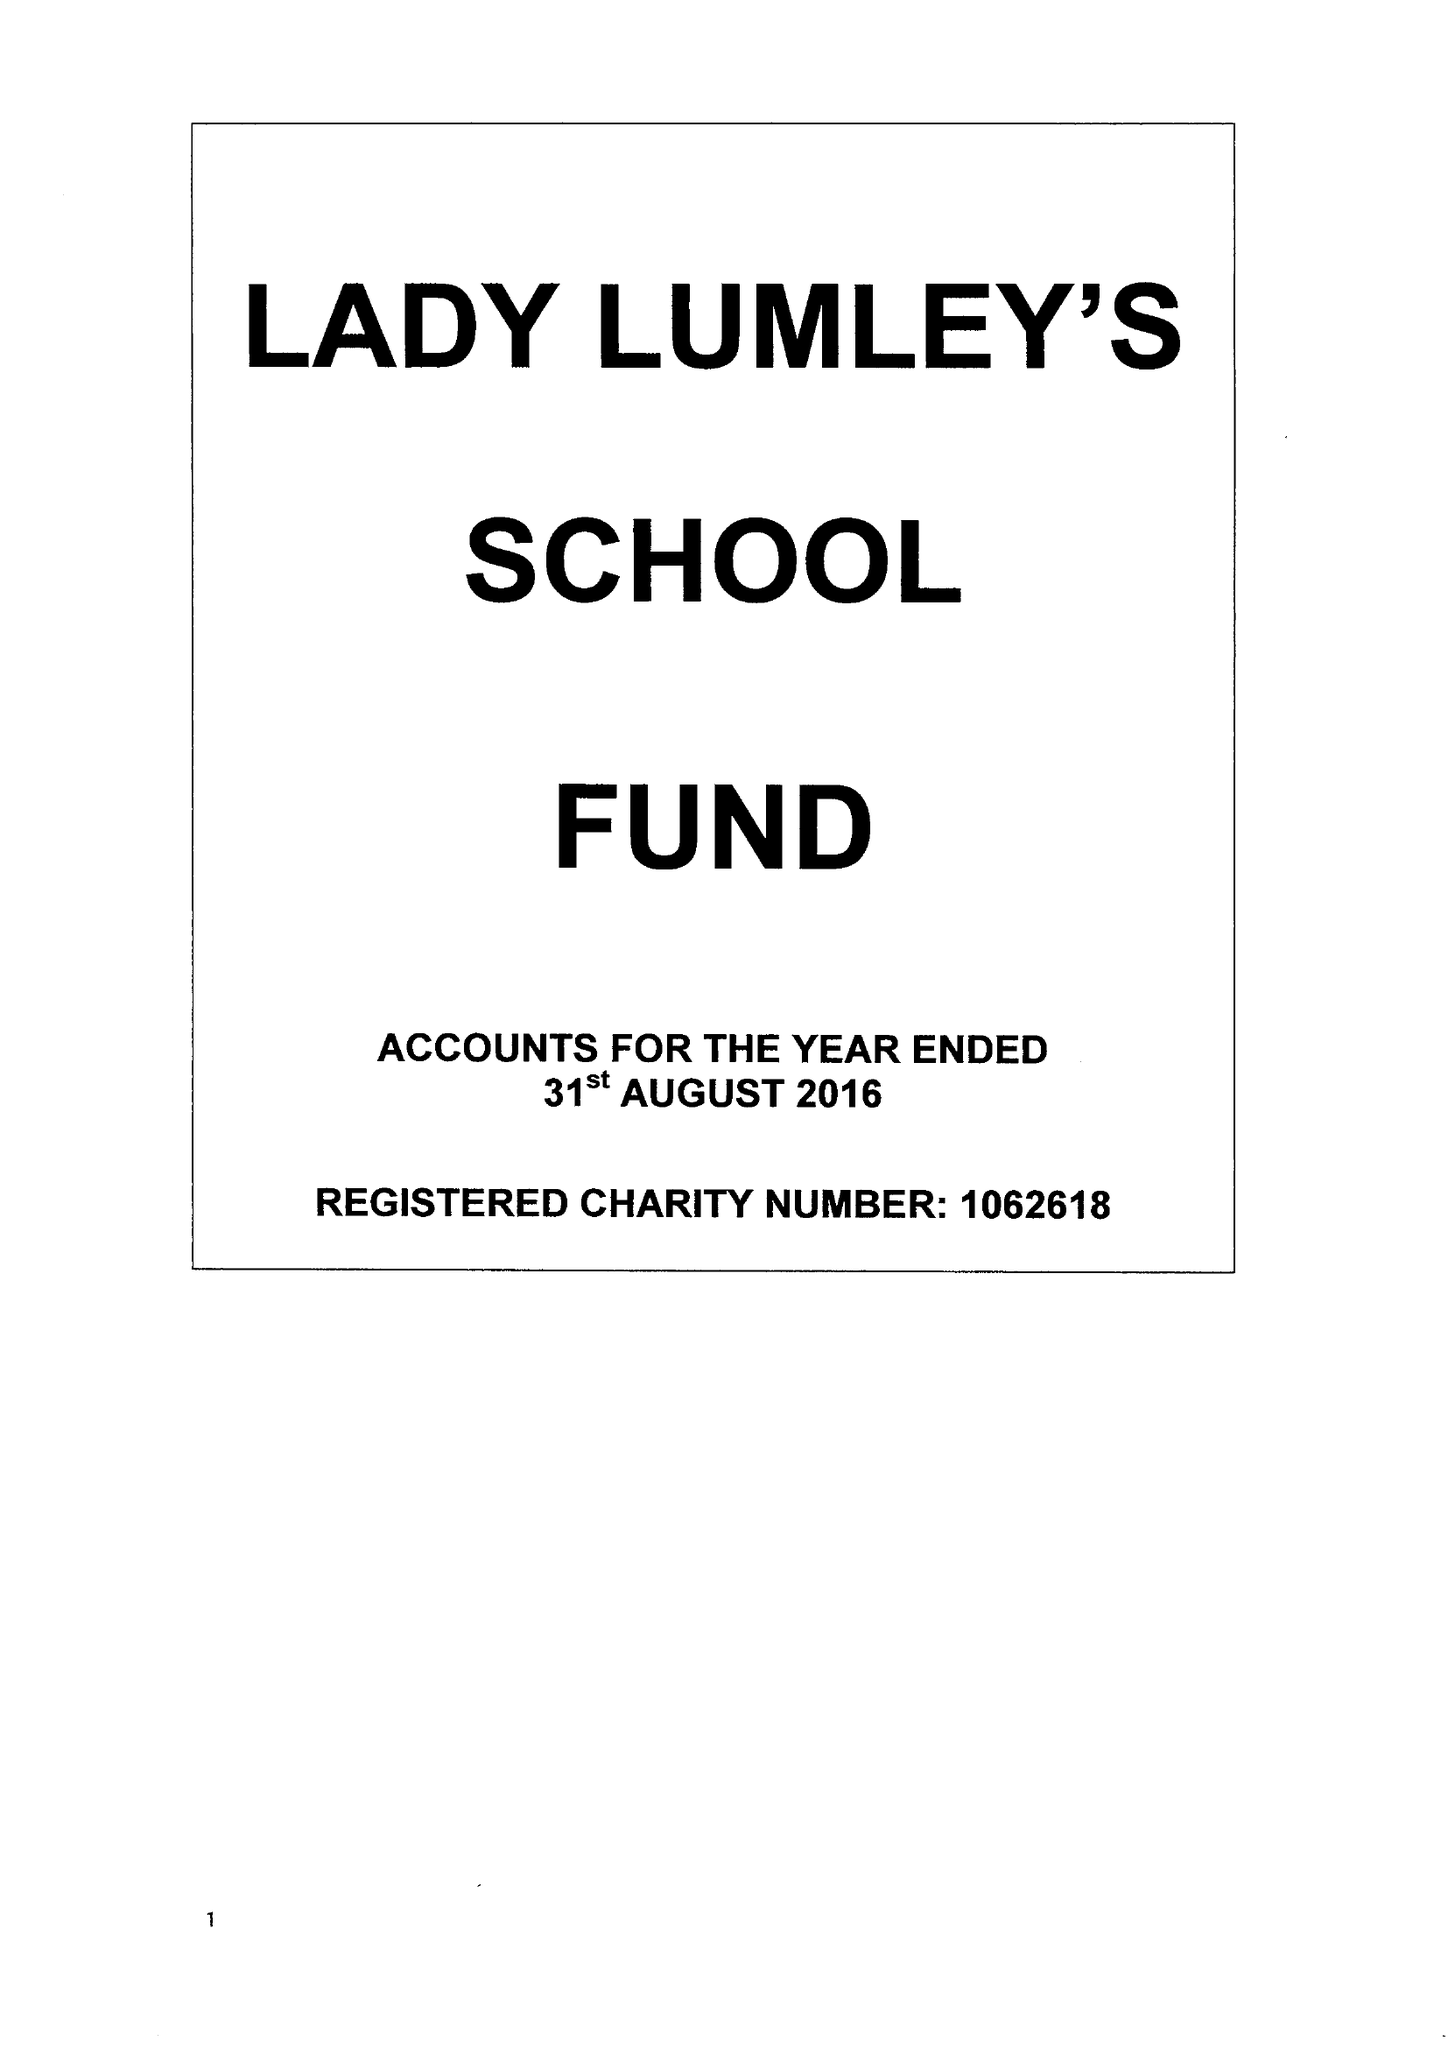What is the value for the address__street_line?
Answer the question using a single word or phrase. SWAINSEA LANE 